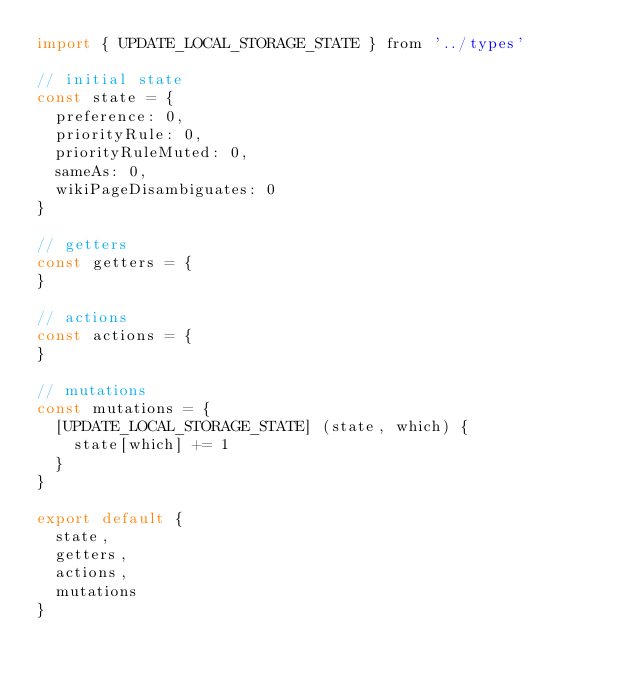Convert code to text. <code><loc_0><loc_0><loc_500><loc_500><_JavaScript_>import { UPDATE_LOCAL_STORAGE_STATE } from '../types'

// initial state
const state = {
  preference: 0,
  priorityRule: 0,
  priorityRuleMuted: 0,
  sameAs: 0,
  wikiPageDisambiguates: 0
}

// getters
const getters = {
}

// actions
const actions = {
}

// mutations
const mutations = {
  [UPDATE_LOCAL_STORAGE_STATE] (state, which) {
    state[which] += 1
  }
}

export default {
  state,
  getters,
  actions,
  mutations
}
</code> 